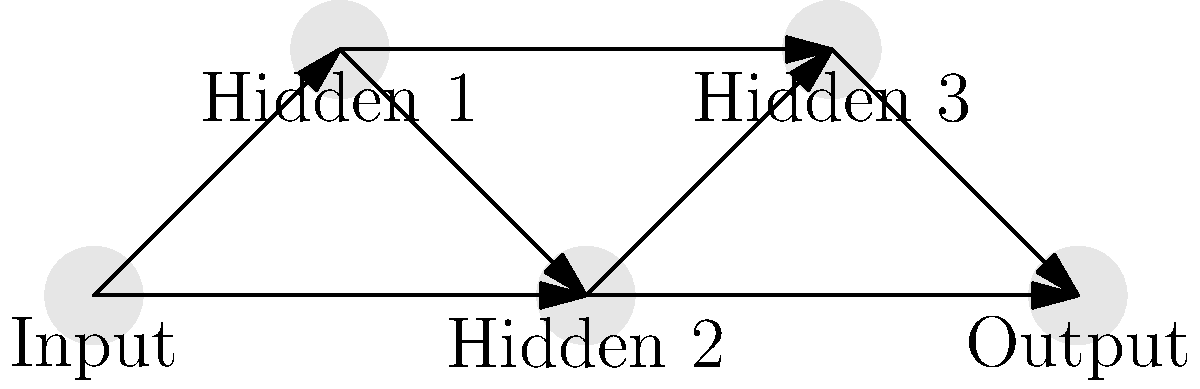Analyze the neural network architecture diagram for player performance prediction. What type of neural network is represented, and what potential issue might arise in training this network for predicting basketball player performance? To analyze this neural network architecture:

1. Observe the structure:
   - The network has 5 layers: 1 input, 3 hidden, and 1 output.
   - Each layer is connected to the next 1-2 layers, not just the immediate next layer.

2. Identify the network type:
   - This is a feedforward neural network with skip connections.
   - The skip connections (e.g., from Input to Hidden 2) allow information to bypass intermediate layers.

3. Consider the implications for player performance prediction:
   - Skip connections can help mitigate the vanishing gradient problem.
   - They allow the network to learn both low-level and high-level features.

4. Potential issue in training:
   - The main concern is overfitting, especially if the dataset is small.
   - With many connections, the network has a high capacity to memorize training data.
   - This could lead to poor generalization on new, unseen player data.

5. Mitigation strategies:
   - Implement regularization techniques (e.g., L1, L2, dropout).
   - Use a larger dataset of player statistics.
   - Employ cross-validation to tune hyperparameters.

The network type and potential overfitting issue are key to answering the question.
Answer: Feedforward network with skip connections; potential overfitting 